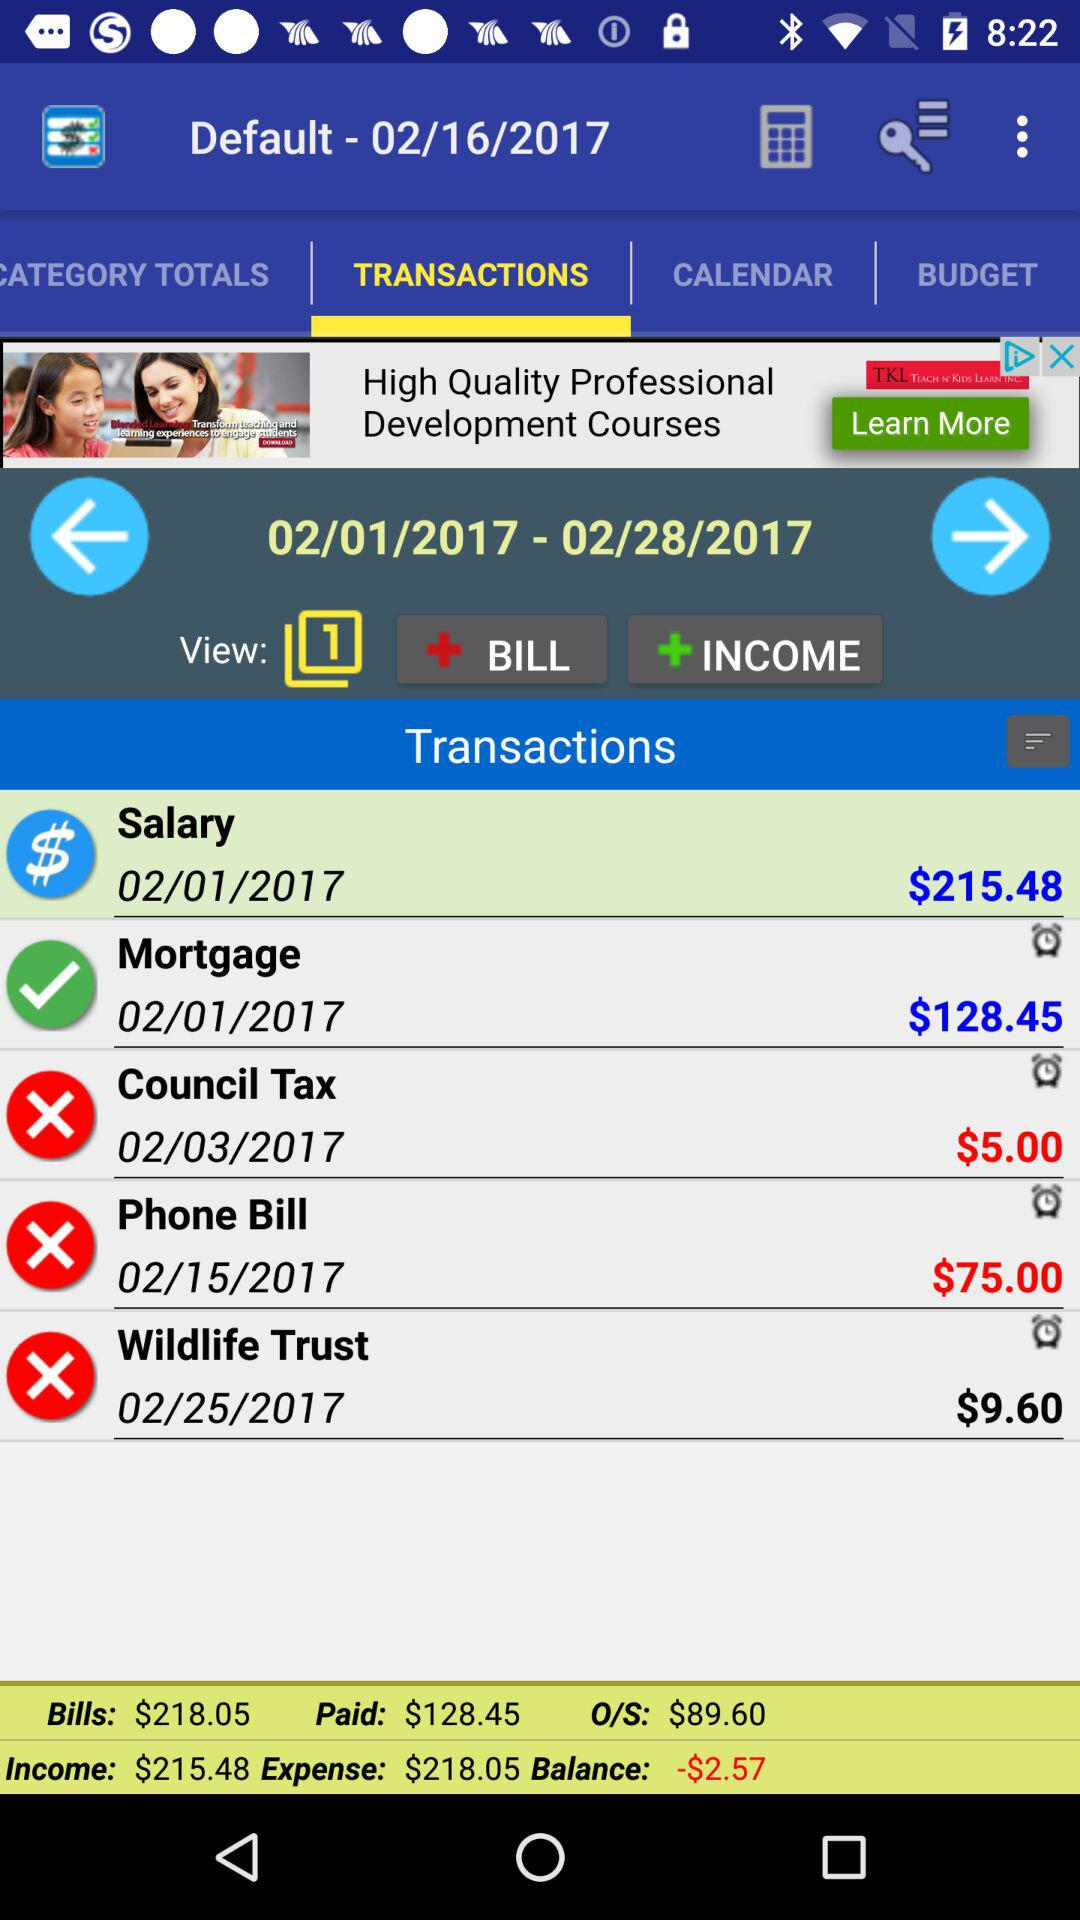What is the amount of the salary? The amount of the salary is $215.48. 